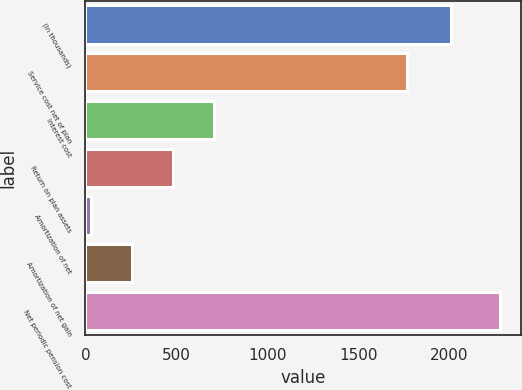Convert chart. <chart><loc_0><loc_0><loc_500><loc_500><bar_chart><fcel>(In thousands)<fcel>Service cost net of plan<fcel>Interest cost<fcel>Return on plan assets<fcel>Amortization of net<fcel>Amortization of net gain<fcel>Net periodic pension cost<nl><fcel>2007<fcel>1767<fcel>706.4<fcel>481.6<fcel>32<fcel>256.8<fcel>2280<nl></chart> 